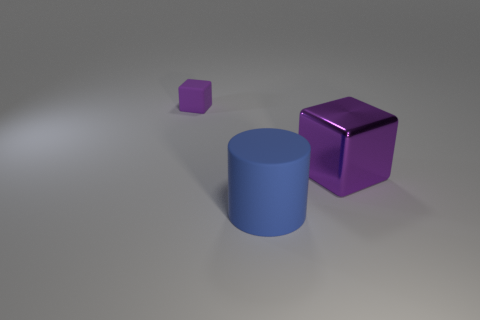Subtract 2 cubes. How many cubes are left? 0 Add 2 purple rubber things. How many objects exist? 5 Subtract all blocks. How many objects are left? 1 Subtract 0 purple cylinders. How many objects are left? 3 Subtract all brown cylinders. Subtract all cyan cubes. How many cylinders are left? 1 Subtract all brown rubber balls. Subtract all matte things. How many objects are left? 1 Add 2 large purple things. How many large purple things are left? 3 Add 1 metal balls. How many metal balls exist? 1 